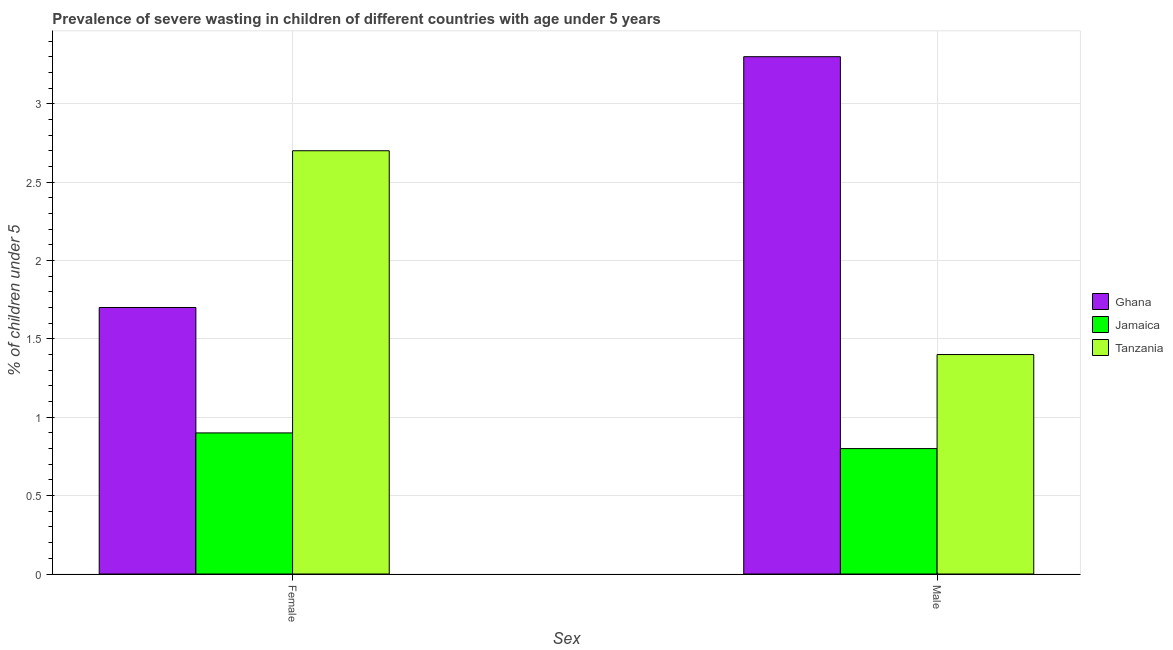How many groups of bars are there?
Your response must be concise. 2. Are the number of bars per tick equal to the number of legend labels?
Give a very brief answer. Yes. Are the number of bars on each tick of the X-axis equal?
Offer a terse response. Yes. How many bars are there on the 1st tick from the left?
Make the answer very short. 3. What is the percentage of undernourished female children in Jamaica?
Offer a very short reply. 0.9. Across all countries, what is the maximum percentage of undernourished male children?
Offer a terse response. 3.3. Across all countries, what is the minimum percentage of undernourished male children?
Provide a succinct answer. 0.8. In which country was the percentage of undernourished female children maximum?
Offer a terse response. Tanzania. In which country was the percentage of undernourished male children minimum?
Ensure brevity in your answer.  Jamaica. What is the total percentage of undernourished female children in the graph?
Offer a very short reply. 5.3. What is the difference between the percentage of undernourished female children in Tanzania and that in Jamaica?
Ensure brevity in your answer.  1.8. What is the difference between the percentage of undernourished female children in Tanzania and the percentage of undernourished male children in Jamaica?
Your response must be concise. 1.9. What is the average percentage of undernourished female children per country?
Your answer should be compact. 1.77. What is the difference between the percentage of undernourished female children and percentage of undernourished male children in Tanzania?
Your answer should be very brief. 1.3. What is the ratio of the percentage of undernourished female children in Ghana to that in Tanzania?
Provide a short and direct response. 0.63. What does the 1st bar from the left in Female represents?
Ensure brevity in your answer.  Ghana. What does the 3rd bar from the right in Female represents?
Offer a terse response. Ghana. Are the values on the major ticks of Y-axis written in scientific E-notation?
Your response must be concise. No. Does the graph contain any zero values?
Your response must be concise. No. Does the graph contain grids?
Your answer should be very brief. Yes. Where does the legend appear in the graph?
Offer a very short reply. Center right. How many legend labels are there?
Give a very brief answer. 3. What is the title of the graph?
Give a very brief answer. Prevalence of severe wasting in children of different countries with age under 5 years. What is the label or title of the X-axis?
Offer a very short reply. Sex. What is the label or title of the Y-axis?
Your answer should be very brief.  % of children under 5. What is the  % of children under 5 of Ghana in Female?
Offer a terse response. 1.7. What is the  % of children under 5 of Jamaica in Female?
Your response must be concise. 0.9. What is the  % of children under 5 in Tanzania in Female?
Your answer should be very brief. 2.7. What is the  % of children under 5 of Ghana in Male?
Your answer should be very brief. 3.3. What is the  % of children under 5 in Jamaica in Male?
Make the answer very short. 0.8. What is the  % of children under 5 in Tanzania in Male?
Provide a succinct answer. 1.4. Across all Sex, what is the maximum  % of children under 5 in Ghana?
Give a very brief answer. 3.3. Across all Sex, what is the maximum  % of children under 5 of Jamaica?
Offer a very short reply. 0.9. Across all Sex, what is the maximum  % of children under 5 in Tanzania?
Your response must be concise. 2.7. Across all Sex, what is the minimum  % of children under 5 in Ghana?
Make the answer very short. 1.7. Across all Sex, what is the minimum  % of children under 5 of Jamaica?
Your answer should be very brief. 0.8. Across all Sex, what is the minimum  % of children under 5 of Tanzania?
Offer a terse response. 1.4. What is the total  % of children under 5 in Tanzania in the graph?
Keep it short and to the point. 4.1. What is the difference between the  % of children under 5 of Ghana in Female and that in Male?
Provide a short and direct response. -1.6. What is the difference between the  % of children under 5 of Tanzania in Female and that in Male?
Keep it short and to the point. 1.3. What is the difference between the  % of children under 5 in Ghana in Female and the  % of children under 5 in Jamaica in Male?
Keep it short and to the point. 0.9. What is the average  % of children under 5 in Ghana per Sex?
Give a very brief answer. 2.5. What is the average  % of children under 5 in Jamaica per Sex?
Provide a succinct answer. 0.85. What is the average  % of children under 5 in Tanzania per Sex?
Offer a terse response. 2.05. What is the difference between the  % of children under 5 in Ghana and  % of children under 5 in Jamaica in Female?
Your answer should be very brief. 0.8. What is the difference between the  % of children under 5 of Ghana and  % of children under 5 of Tanzania in Male?
Offer a terse response. 1.9. What is the difference between the  % of children under 5 of Jamaica and  % of children under 5 of Tanzania in Male?
Keep it short and to the point. -0.6. What is the ratio of the  % of children under 5 in Ghana in Female to that in Male?
Offer a very short reply. 0.52. What is the ratio of the  % of children under 5 in Jamaica in Female to that in Male?
Provide a succinct answer. 1.12. What is the ratio of the  % of children under 5 in Tanzania in Female to that in Male?
Make the answer very short. 1.93. What is the difference between the highest and the second highest  % of children under 5 in Ghana?
Offer a very short reply. 1.6. What is the difference between the highest and the second highest  % of children under 5 of Jamaica?
Make the answer very short. 0.1. What is the difference between the highest and the second highest  % of children under 5 in Tanzania?
Ensure brevity in your answer.  1.3. What is the difference between the highest and the lowest  % of children under 5 of Tanzania?
Keep it short and to the point. 1.3. 